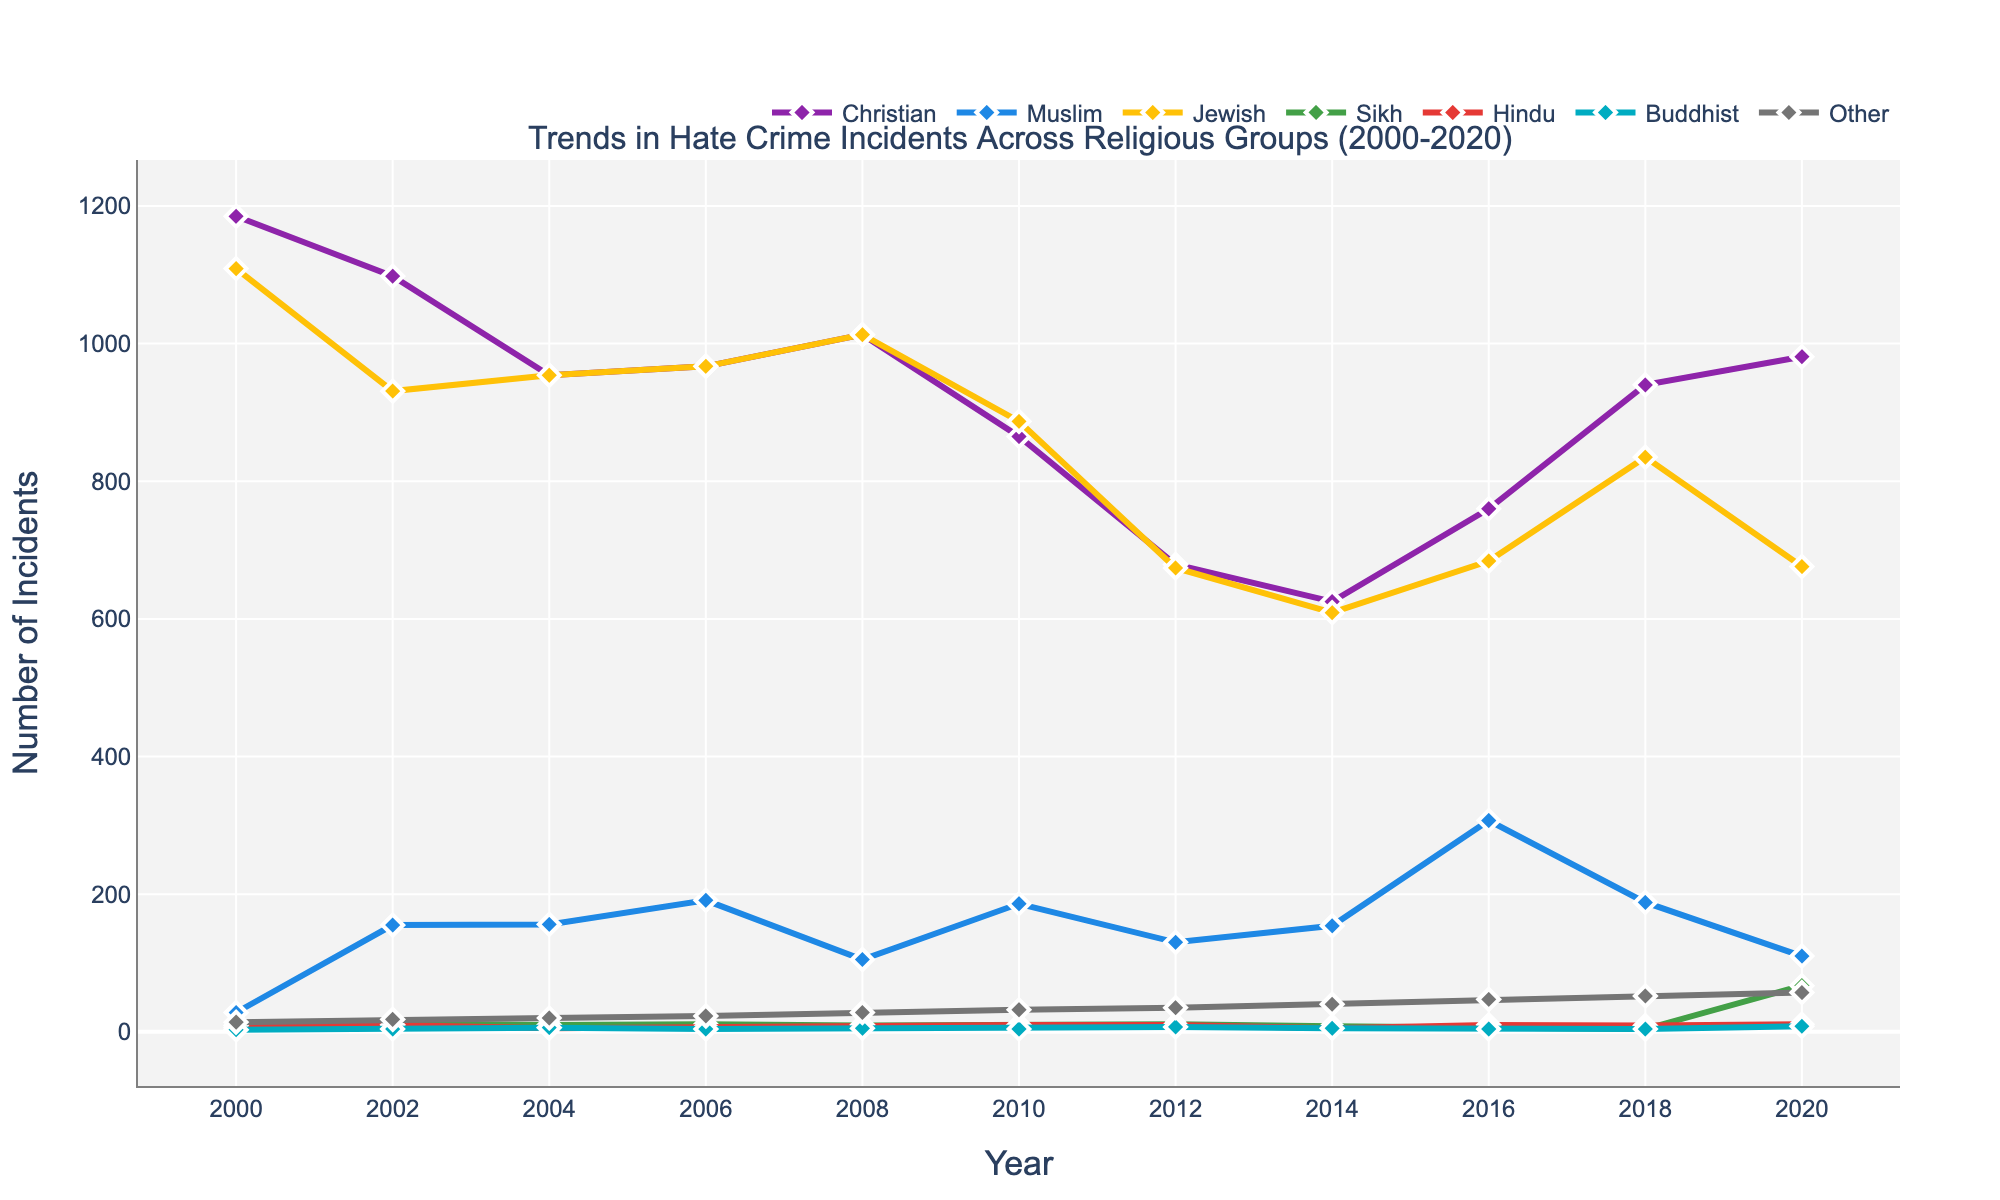Which year had the highest number of hate crimes against Christians? By looking at the trend line for Christians, the highest point is in the year 2000.
Answer: 2000 Which religious group experienced the highest number of hate crimes in 2016? By comparing the heights of all the trend lines in 2016, Muslims experienced the highest number of hate crimes.
Answer: Muslims How did the number of hate crime incidents against Sikhs change from 2018 to 2020? Noticing the trend line for Sikhs, the number of incidents increased significantly from 4 to 67 between these years.
Answer: Increased What is the average number of hate crime incidents against Jewish people over the entire period? Sum the incidents for Jewish people from 2000-2020 and divide by the number of years ((1109 + 931 + 954 + 967 + 1013 + 887 + 674 + 609 + 684 + 835 + 676) / 11). The calculation is 9339 / 11.
Answer: 849 Which religious group had the lowest number of hate crimes in 2008? By examining the line chart, Buddhists had the lowest hate crimes in 2008 with only 5 incidents.
Answer: Buddhists Compare the trend of hate crimes between Muslims and Jews from 2000 to 2020. By observing both trend lines for Muslims and Jews, Muslims have a fluctuating but generally increasing trend, while the trend for Jews is generally decreasing over the same period.
Answer: Different trends How many years did hate crime incidents against Hindus remain constant? Lines for Hindus are flat in most intervals except for 2008-2020, thus there is no variation over 6 years.
Answer: 6 years What was the difference in hate crime incidents against Christians between 2000 and 2012? There's a notable decrease, calculated by subtracting 1185 (in 2000) from 679 (in 2012). The difference is 506 incidents.
Answer: 506 Which religious group's incidents remained below 100 for most of the timeframe? Scanning all trend lines, "Other" religious groups consistently showed incidents below 100 across the years.
Answer: Other 